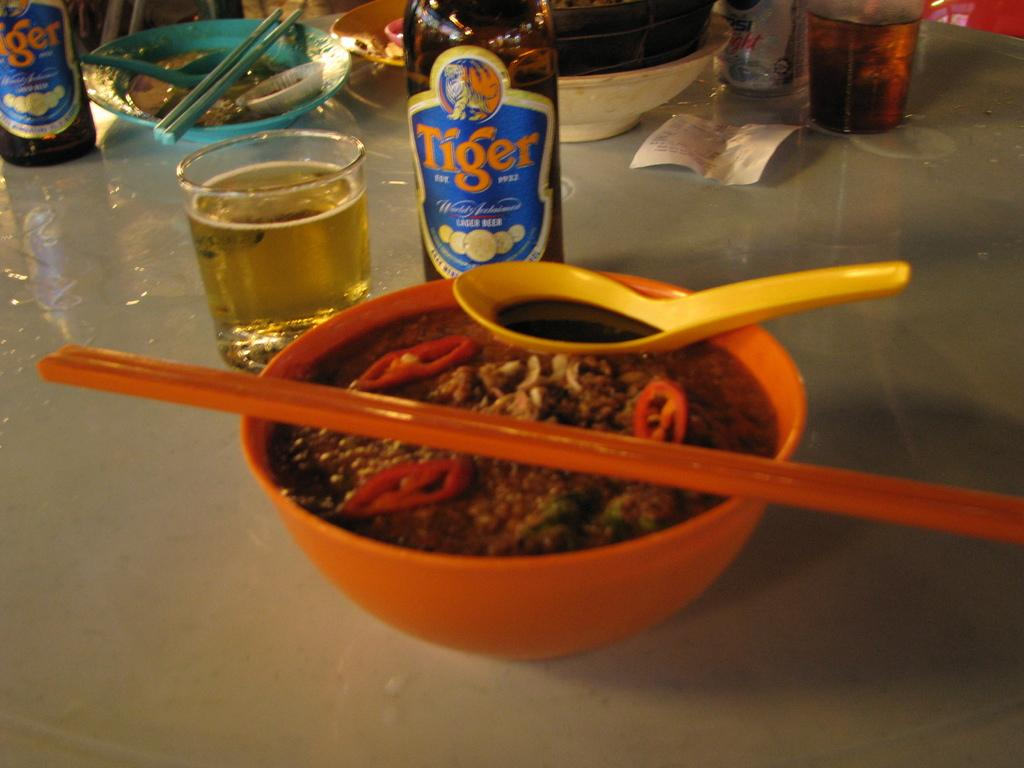What type of bottle is visible in the image? There is a beer bottle in the image. What other container can be seen in the image? There is a glass in the image. What is in the bowl that is visible in the image? There is a bowl of food in the image. Where are the beer bottle, glass, and bowl of food located? The beer bottle, glass, and bowl of food are on a table. What type of shoes are visible in the image? There are no shoes present in the image. What type of eggnog can be seen in the glass? There is no eggnog present in the image; it is a glass of liquid, but the specific type is not mentioned. 